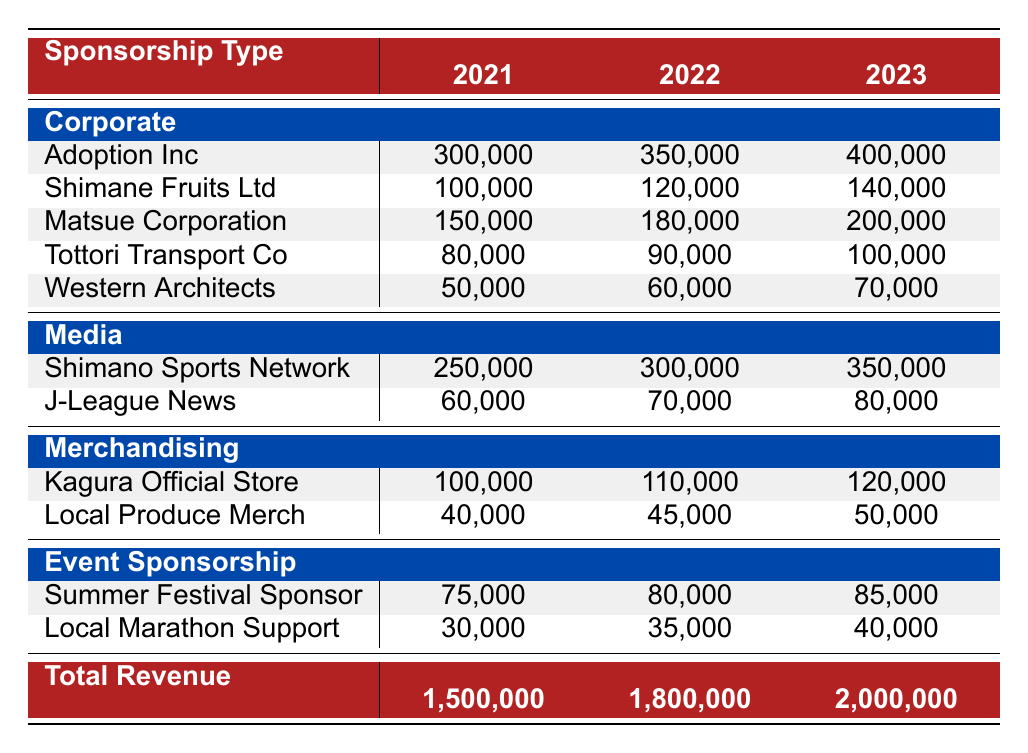What was the total revenue for Kagura Shimane Football Club in 2022? The total revenue for 2022 is specifically listed in the table under the "Total Revenue" row, which shows a value of 1,800,000.
Answer: 1,800,000 Which corporate sponsor contributed the most in 2023? In the "Corporate" sponsorship section for 2023, comparing all figures shows that Adoption Inc contributed the highest amount at 400,000.
Answer: Adoption Inc What is the average revenue from event sponsorship over the three years? The total revenue from event sponsorship for each year is 75,000 (2021) + 80,000 (2022) + 85,000 (2023) = 240,000. Dividing by the three years gives an average of 240,000 / 3 = 80,000.
Answer: 80,000 Did Shimano Sports Network increase its contribution each year? By examining the values in the "Media" sponsorship section, Shimano Sports Network shows contributions of 250,000 (2021), 300,000 (2022), and 350,000 (2023), confirming an increase each year.
Answer: Yes What percentage of total revenue did Matsue Corporation contribute in 2023? Matsue Corporation's contribution in 2023 is 200,000. The total revenue for 2023 is 2,000,000. Calculating the percentage gives (200,000 / 2,000,000) * 100 = 10%.
Answer: 10% How much did Kagura Official Store contribute in total over the three years? Adding the contributions from Kagura Official Store: 100,000 (2021) + 110,000 (2022) + 120,000 (2023) equals 330,000.
Answer: 330,000 What is the trend in total revenue from 2021 to 2023? The total revenue increased from 1,500,000 in 2021 to 1,800,000 in 2022 and then to 2,000,000 in 2023, indicating a positive trend of growth over the three years.
Answer: Increasing Which category had the lowest total contribution in 2021? By looking at the total sums for each category in 2021: Corporate (300,000 + 100,000 + 150,000 + 80,000 + 50,000 = 680,000), Media (250,000 + 60,000 = 310,000), Merchandising (100,000 + 40,000 = 140,000), Event Sponsorship (75,000 + 30,000 = 105,000). The lowest total is 105,000 for Event Sponsorship.
Answer: Event Sponsorship What was the contribution increase for Shimane Fruits Ltd from 2021 to 2023? Shimane Fruits Ltd's contributions were 100,000 in 2021 and 140,000 in 2023. The increase is 140,000 - 100,000 = 40,000 over the two years.
Answer: 40,000 How much total revenue did the media category generate in 2022? For the media category in 2022, Shimano Sports Network contributed 300,000 and J-League News contributed 70,000. Summing these gives 300,000 + 70,000 = 370,000.
Answer: 370,000 